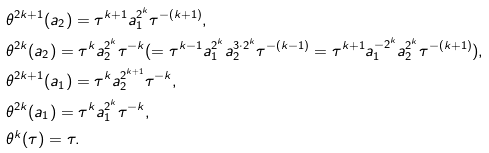<formula> <loc_0><loc_0><loc_500><loc_500>& \theta ^ { 2 k + 1 } ( a _ { 2 } ) = \tau ^ { k + 1 } a _ { 1 } ^ { 2 ^ { k } } \tau ^ { - ( k + 1 ) } , \\ & \theta ^ { 2 k } ( a _ { 2 } ) = \tau ^ { k } a _ { 2 } ^ { 2 ^ { k } } \tau ^ { - k } ( = \tau ^ { k - 1 } a _ { 1 } ^ { 2 ^ { k } } a _ { 2 } ^ { 3 \cdot 2 ^ { k } } \tau ^ { - ( k - 1 ) } = \tau ^ { k + 1 } a _ { 1 } ^ { - 2 ^ { k } } a _ { 2 } ^ { 2 ^ { k } } \tau ^ { - ( k + 1 ) } ) , \\ & \theta ^ { 2 k + 1 } ( a _ { 1 } ) = \tau ^ { k } a _ { 2 } ^ { 2 ^ { k + 1 } } \tau ^ { - k } , \\ & \theta ^ { 2 k } ( a _ { 1 } ) = \tau ^ { k } a _ { 1 } ^ { 2 ^ { k } } \tau ^ { - k } , \\ & \theta ^ { k } ( \tau ) = \tau .</formula> 